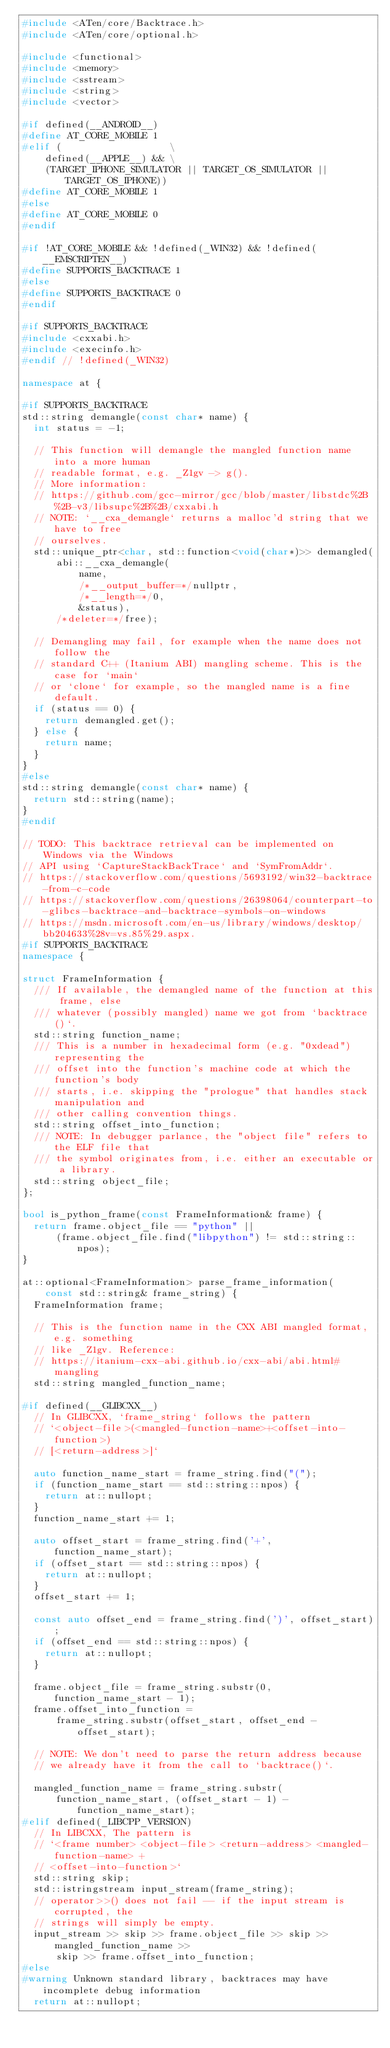<code> <loc_0><loc_0><loc_500><loc_500><_C++_>#include <ATen/core/Backtrace.h>
#include <ATen/core/optional.h>

#include <functional>
#include <memory>
#include <sstream>
#include <string>
#include <vector>

#if defined(__ANDROID__)
#define AT_CORE_MOBILE 1
#elif (                   \
    defined(__APPLE__) && \
    (TARGET_IPHONE_SIMULATOR || TARGET_OS_SIMULATOR || TARGET_OS_IPHONE))
#define AT_CORE_MOBILE 1
#else
#define AT_CORE_MOBILE 0
#endif

#if !AT_CORE_MOBILE && !defined(_WIN32) && !defined(__EMSCRIPTEN__)
#define SUPPORTS_BACKTRACE 1
#else
#define SUPPORTS_BACKTRACE 0
#endif

#if SUPPORTS_BACKTRACE
#include <cxxabi.h>
#include <execinfo.h>
#endif // !defined(_WIN32)

namespace at {

#if SUPPORTS_BACKTRACE
std::string demangle(const char* name) {
  int status = -1;

  // This function will demangle the mangled function name into a more human
  // readable format, e.g. _Z1gv -> g().
  // More information:
  // https://github.com/gcc-mirror/gcc/blob/master/libstdc%2B%2B-v3/libsupc%2B%2B/cxxabi.h
  // NOTE: `__cxa_demangle` returns a malloc'd string that we have to free
  // ourselves.
  std::unique_ptr<char, std::function<void(char*)>> demangled(
      abi::__cxa_demangle(
          name,
          /*__output_buffer=*/nullptr,
          /*__length=*/0,
          &status),
      /*deleter=*/free);

  // Demangling may fail, for example when the name does not follow the
  // standard C++ (Itanium ABI) mangling scheme. This is the case for `main`
  // or `clone` for example, so the mangled name is a fine default.
  if (status == 0) {
    return demangled.get();
  } else {
    return name;
  }
}
#else
std::string demangle(const char* name) {
  return std::string(name);
}
#endif

// TODO: This backtrace retrieval can be implemented on Windows via the Windows
// API using `CaptureStackBackTrace` and `SymFromAddr`.
// https://stackoverflow.com/questions/5693192/win32-backtrace-from-c-code
// https://stackoverflow.com/questions/26398064/counterpart-to-glibcs-backtrace-and-backtrace-symbols-on-windows
// https://msdn.microsoft.com/en-us/library/windows/desktop/bb204633%28v=vs.85%29.aspx.
#if SUPPORTS_BACKTRACE
namespace {

struct FrameInformation {
  /// If available, the demangled name of the function at this frame, else
  /// whatever (possibly mangled) name we got from `backtrace()`.
  std::string function_name;
  /// This is a number in hexadecimal form (e.g. "0xdead") representing the
  /// offset into the function's machine code at which the function's body
  /// starts, i.e. skipping the "prologue" that handles stack manipulation and
  /// other calling convention things.
  std::string offset_into_function;
  /// NOTE: In debugger parlance, the "object file" refers to the ELF file that
  /// the symbol originates from, i.e. either an executable or a library.
  std::string object_file;
};

bool is_python_frame(const FrameInformation& frame) {
  return frame.object_file == "python" ||
      (frame.object_file.find("libpython") != std::string::npos);
}

at::optional<FrameInformation> parse_frame_information(
    const std::string& frame_string) {
  FrameInformation frame;

  // This is the function name in the CXX ABI mangled format, e.g. something
  // like _Z1gv. Reference:
  // https://itanium-cxx-abi.github.io/cxx-abi/abi.html#mangling
  std::string mangled_function_name;

#if defined(__GLIBCXX__)
  // In GLIBCXX, `frame_string` follows the pattern
  // `<object-file>(<mangled-function-name>+<offset-into-function>)
  // [<return-address>]`

  auto function_name_start = frame_string.find("(");
  if (function_name_start == std::string::npos) {
    return at::nullopt;
  }
  function_name_start += 1;

  auto offset_start = frame_string.find('+', function_name_start);
  if (offset_start == std::string::npos) {
    return at::nullopt;
  }
  offset_start += 1;

  const auto offset_end = frame_string.find(')', offset_start);
  if (offset_end == std::string::npos) {
    return at::nullopt;
  }

  frame.object_file = frame_string.substr(0, function_name_start - 1);
  frame.offset_into_function =
      frame_string.substr(offset_start, offset_end - offset_start);

  // NOTE: We don't need to parse the return address because
  // we already have it from the call to `backtrace()`.

  mangled_function_name = frame_string.substr(
      function_name_start, (offset_start - 1) - function_name_start);
#elif defined(_LIBCPP_VERSION)
  // In LIBCXX, The pattern is
  // `<frame number> <object-file> <return-address> <mangled-function-name> +
  // <offset-into-function>`
  std::string skip;
  std::istringstream input_stream(frame_string);
  // operator>>() does not fail -- if the input stream is corrupted, the
  // strings will simply be empty.
  input_stream >> skip >> frame.object_file >> skip >> mangled_function_name >>
      skip >> frame.offset_into_function;
#else
#warning Unknown standard library, backtraces may have incomplete debug information
  return at::nullopt;</code> 